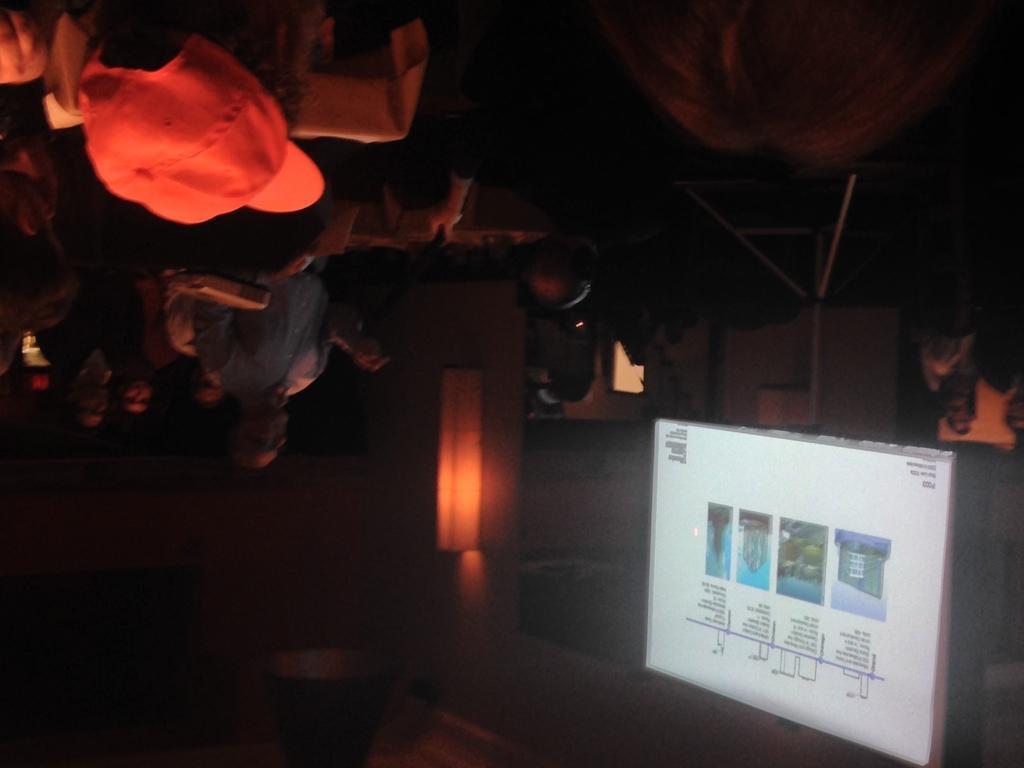Can you describe this image briefly? In this upside down image, in the bottom right there is a board on a tripod stand. There are pictures and text displayed on the board. At the top there are people. Behind the board there is a wall. The image is dark. 